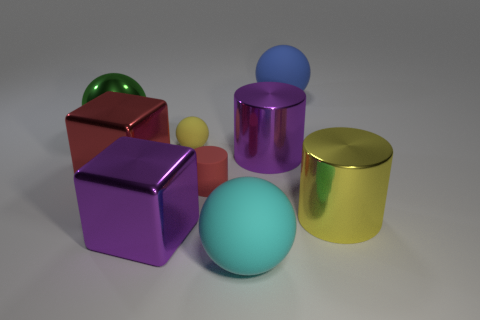Add 1 small yellow things. How many objects exist? 10 Subtract all green metallic balls. How many balls are left? 3 Subtract all green balls. How many balls are left? 3 Subtract 1 blue spheres. How many objects are left? 8 Subtract all cylinders. How many objects are left? 6 Subtract 2 balls. How many balls are left? 2 Subtract all yellow cubes. Subtract all yellow cylinders. How many cubes are left? 2 Subtract all brown cylinders. How many yellow cubes are left? 0 Subtract all balls. Subtract all big gray shiny things. How many objects are left? 5 Add 7 purple shiny objects. How many purple shiny objects are left? 9 